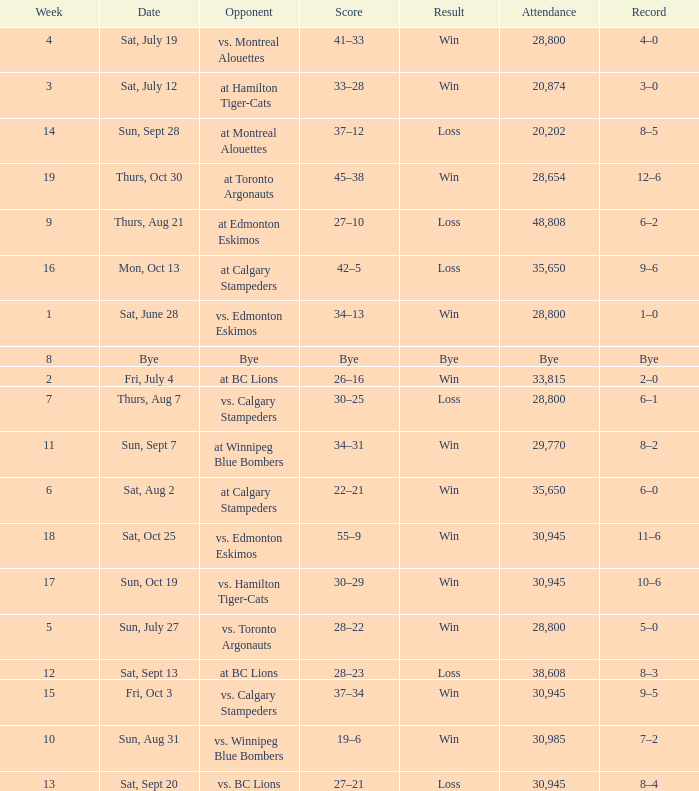What was the record the the match against vs. calgary stampeders before week 15? 6–1. 